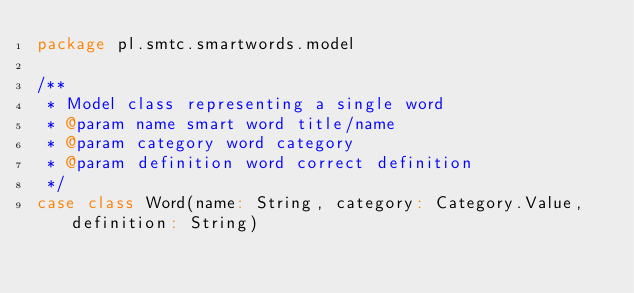Convert code to text. <code><loc_0><loc_0><loc_500><loc_500><_Scala_>package pl.smtc.smartwords.model

/**
 * Model class representing a single word
 * @param name smart word title/name
 * @param category word category
 * @param definition word correct definition
 */
case class Word(name: String, category: Category.Value, definition: String)
</code> 